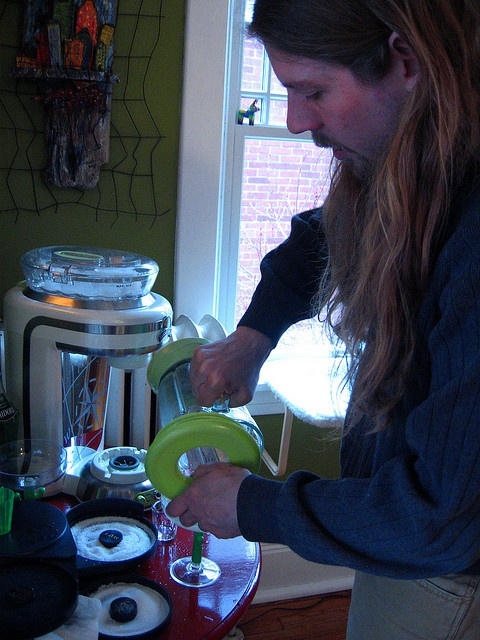Describe the objects in this image and their specific colors. I can see people in black, navy, and purple tones and wine glass in black, lightblue, white, and navy tones in this image. 